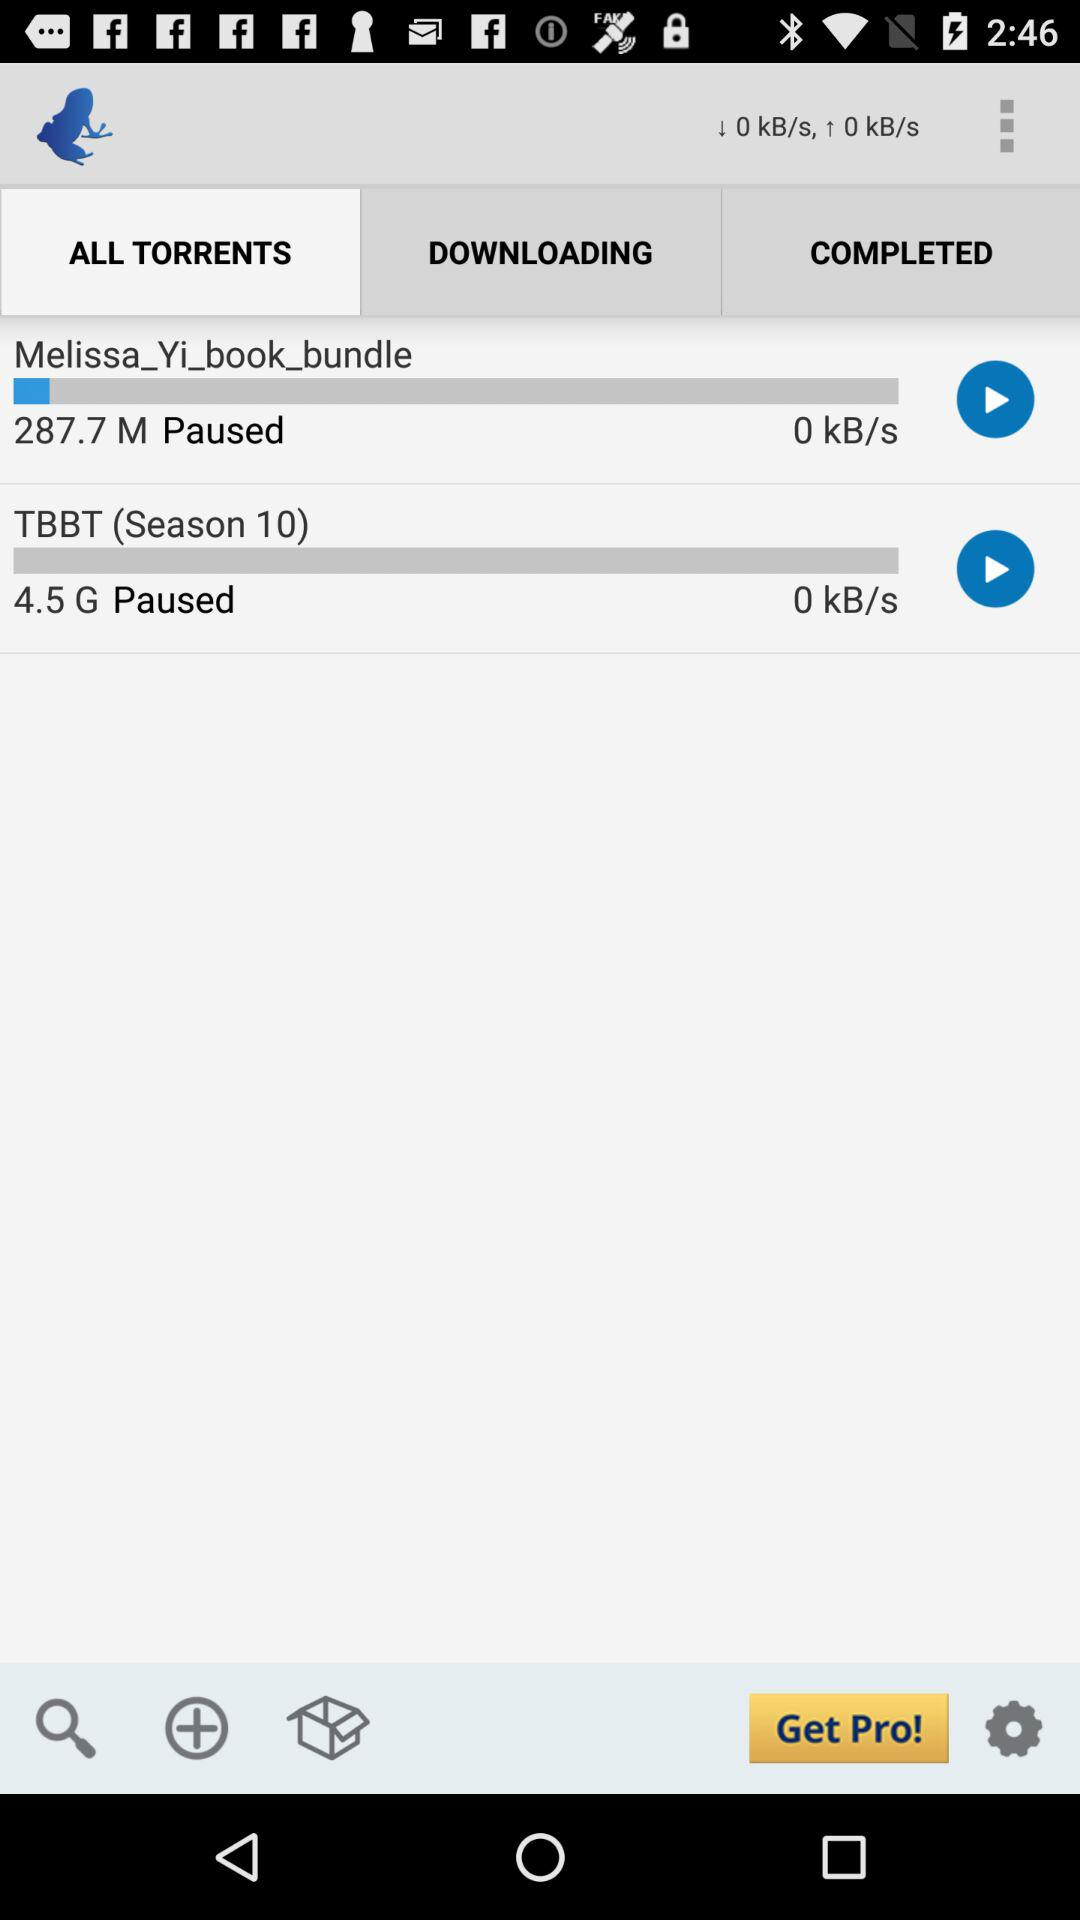How many items are paused?
Answer the question using a single word or phrase. 2 